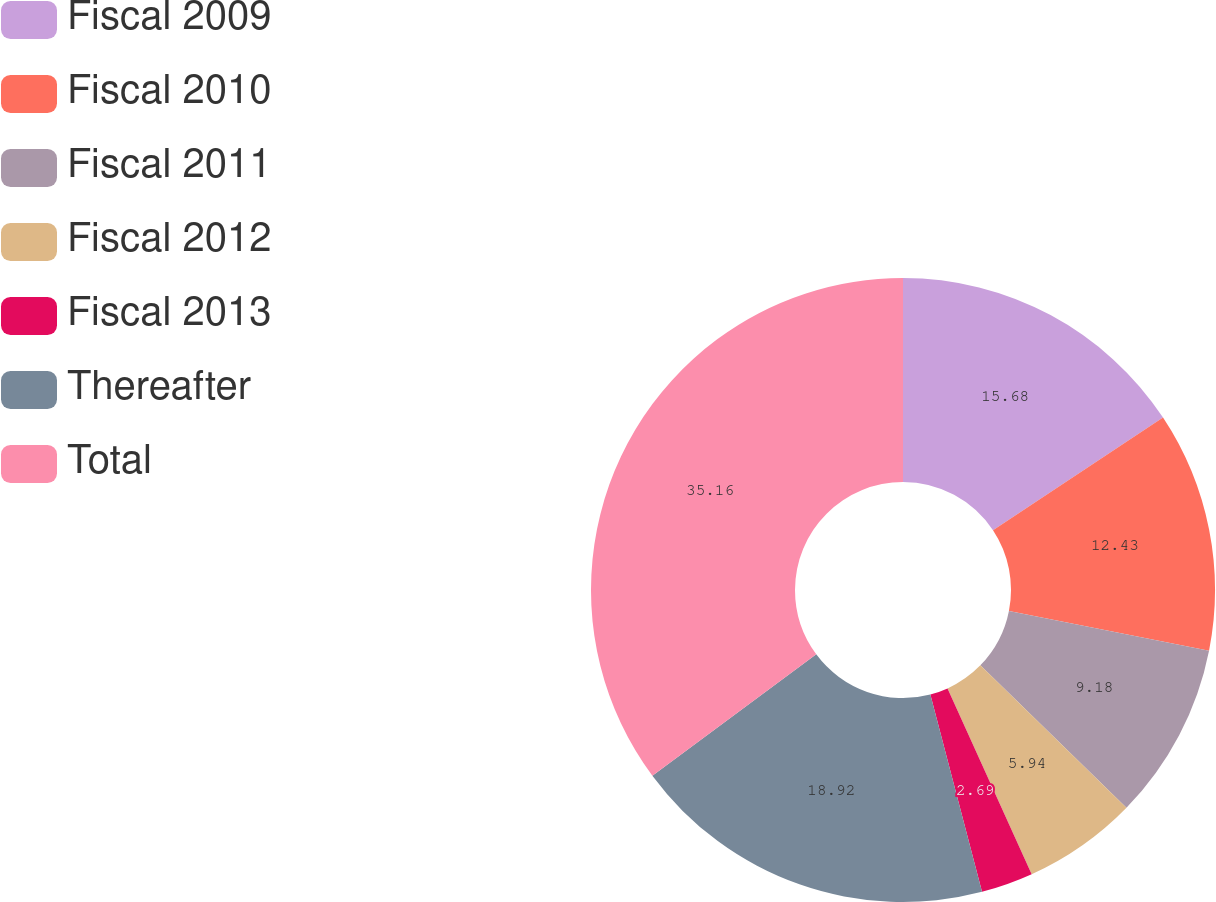Convert chart to OTSL. <chart><loc_0><loc_0><loc_500><loc_500><pie_chart><fcel>Fiscal 2009<fcel>Fiscal 2010<fcel>Fiscal 2011<fcel>Fiscal 2012<fcel>Fiscal 2013<fcel>Thereafter<fcel>Total<nl><fcel>15.68%<fcel>12.43%<fcel>9.18%<fcel>5.94%<fcel>2.69%<fcel>18.92%<fcel>35.15%<nl></chart> 